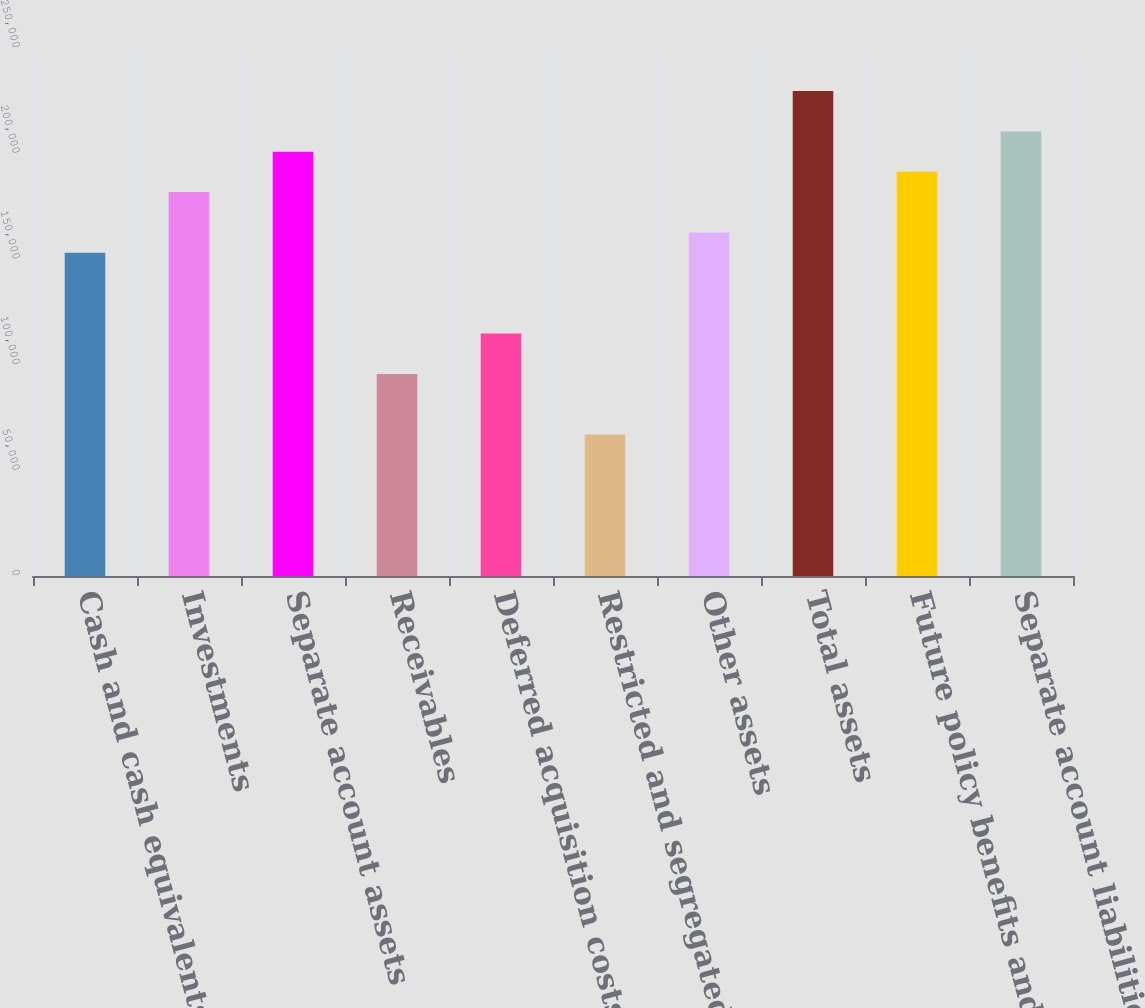Convert chart. <chart><loc_0><loc_0><loc_500><loc_500><bar_chart><fcel>Cash and cash equivalents<fcel>Investments<fcel>Separate account assets<fcel>Receivables<fcel>Deferred acquisition costs<fcel>Restricted and segregated cash<fcel>Other assets<fcel>Total assets<fcel>Future policy benefits and<fcel>Separate account liabilities<nl><fcel>153080<fcel>181782<fcel>200916<fcel>95676<fcel>114811<fcel>66974.1<fcel>162647<fcel>229618<fcel>191349<fcel>210484<nl></chart> 